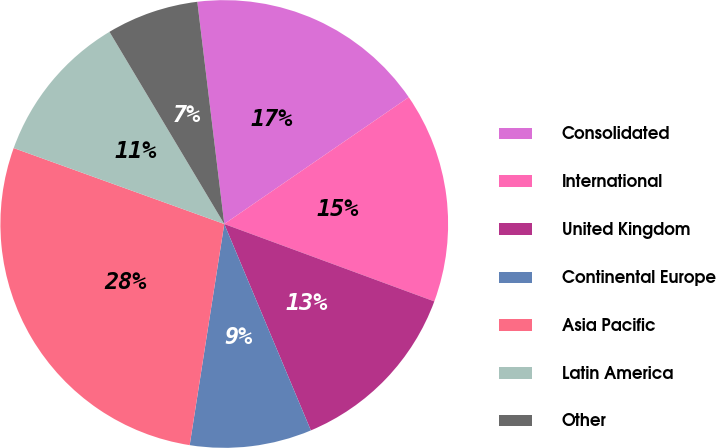Convert chart. <chart><loc_0><loc_0><loc_500><loc_500><pie_chart><fcel>Consolidated<fcel>International<fcel>United Kingdom<fcel>Continental Europe<fcel>Asia Pacific<fcel>Latin America<fcel>Other<nl><fcel>17.34%<fcel>15.2%<fcel>13.06%<fcel>8.79%<fcel>28.04%<fcel>10.92%<fcel>6.65%<nl></chart> 